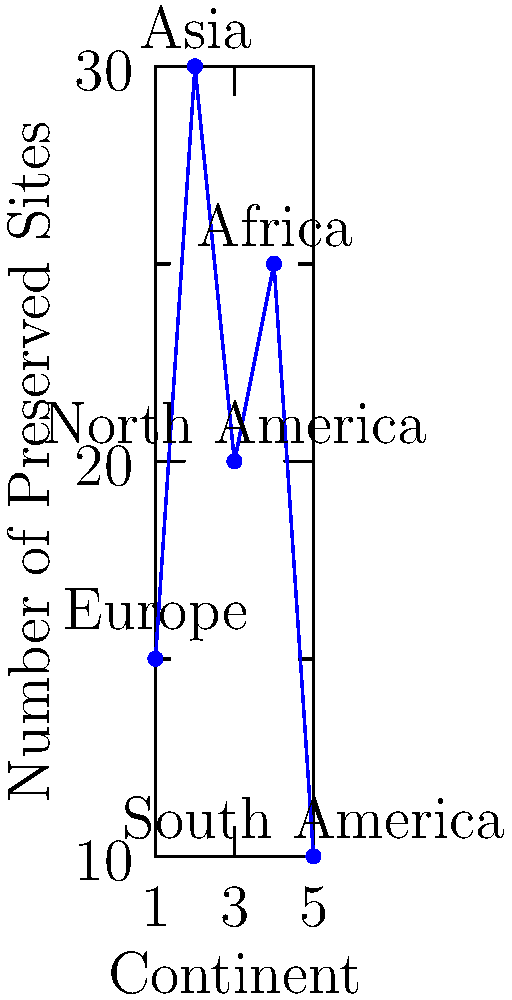Based on the network graph showing the geographical distribution of preserved historical sites across continents, which region has the highest number of sites, and what implications might this have for your feature article on historical preservation? To answer this question, let's analyze the graph step-by-step:

1. The graph shows the number of preserved historical sites for five continents.
2. The x-axis represents the continents, while the y-axis shows the number of preserved sites.
3. Examining the data points:
   - Europe: approximately 15 sites
   - Asia: approximately 30 sites
   - North America: approximately 20 sites
   - Africa: approximately 25 sites
   - South America: approximately 10 sites

4. Asia has the highest peak on the graph, indicating the largest number of preserved historical sites (about 30).

5. Implications for the feature article:
   a) The high number of sites in Asia suggests a rich historical heritage and potentially strong preservation efforts.
   b) It could indicate a greater focus on cultural tourism in Asia.
   c) There might be unique preservation techniques or policies in place in Asian countries.
   d) The disparity between continents could be a point of discussion on global preservation efforts and resource allocation.
   e) It may prompt questions about the criteria for historical site designation across different regions.

6. As a reporter, this data could lead to exploring why Asia has more preserved sites, what can be learned from their preservation methods, and how to promote better preservation in regions with fewer sites.
Answer: Asia; implications include examining Asian preservation methods, global resource allocation, and criteria for historical site designation. 